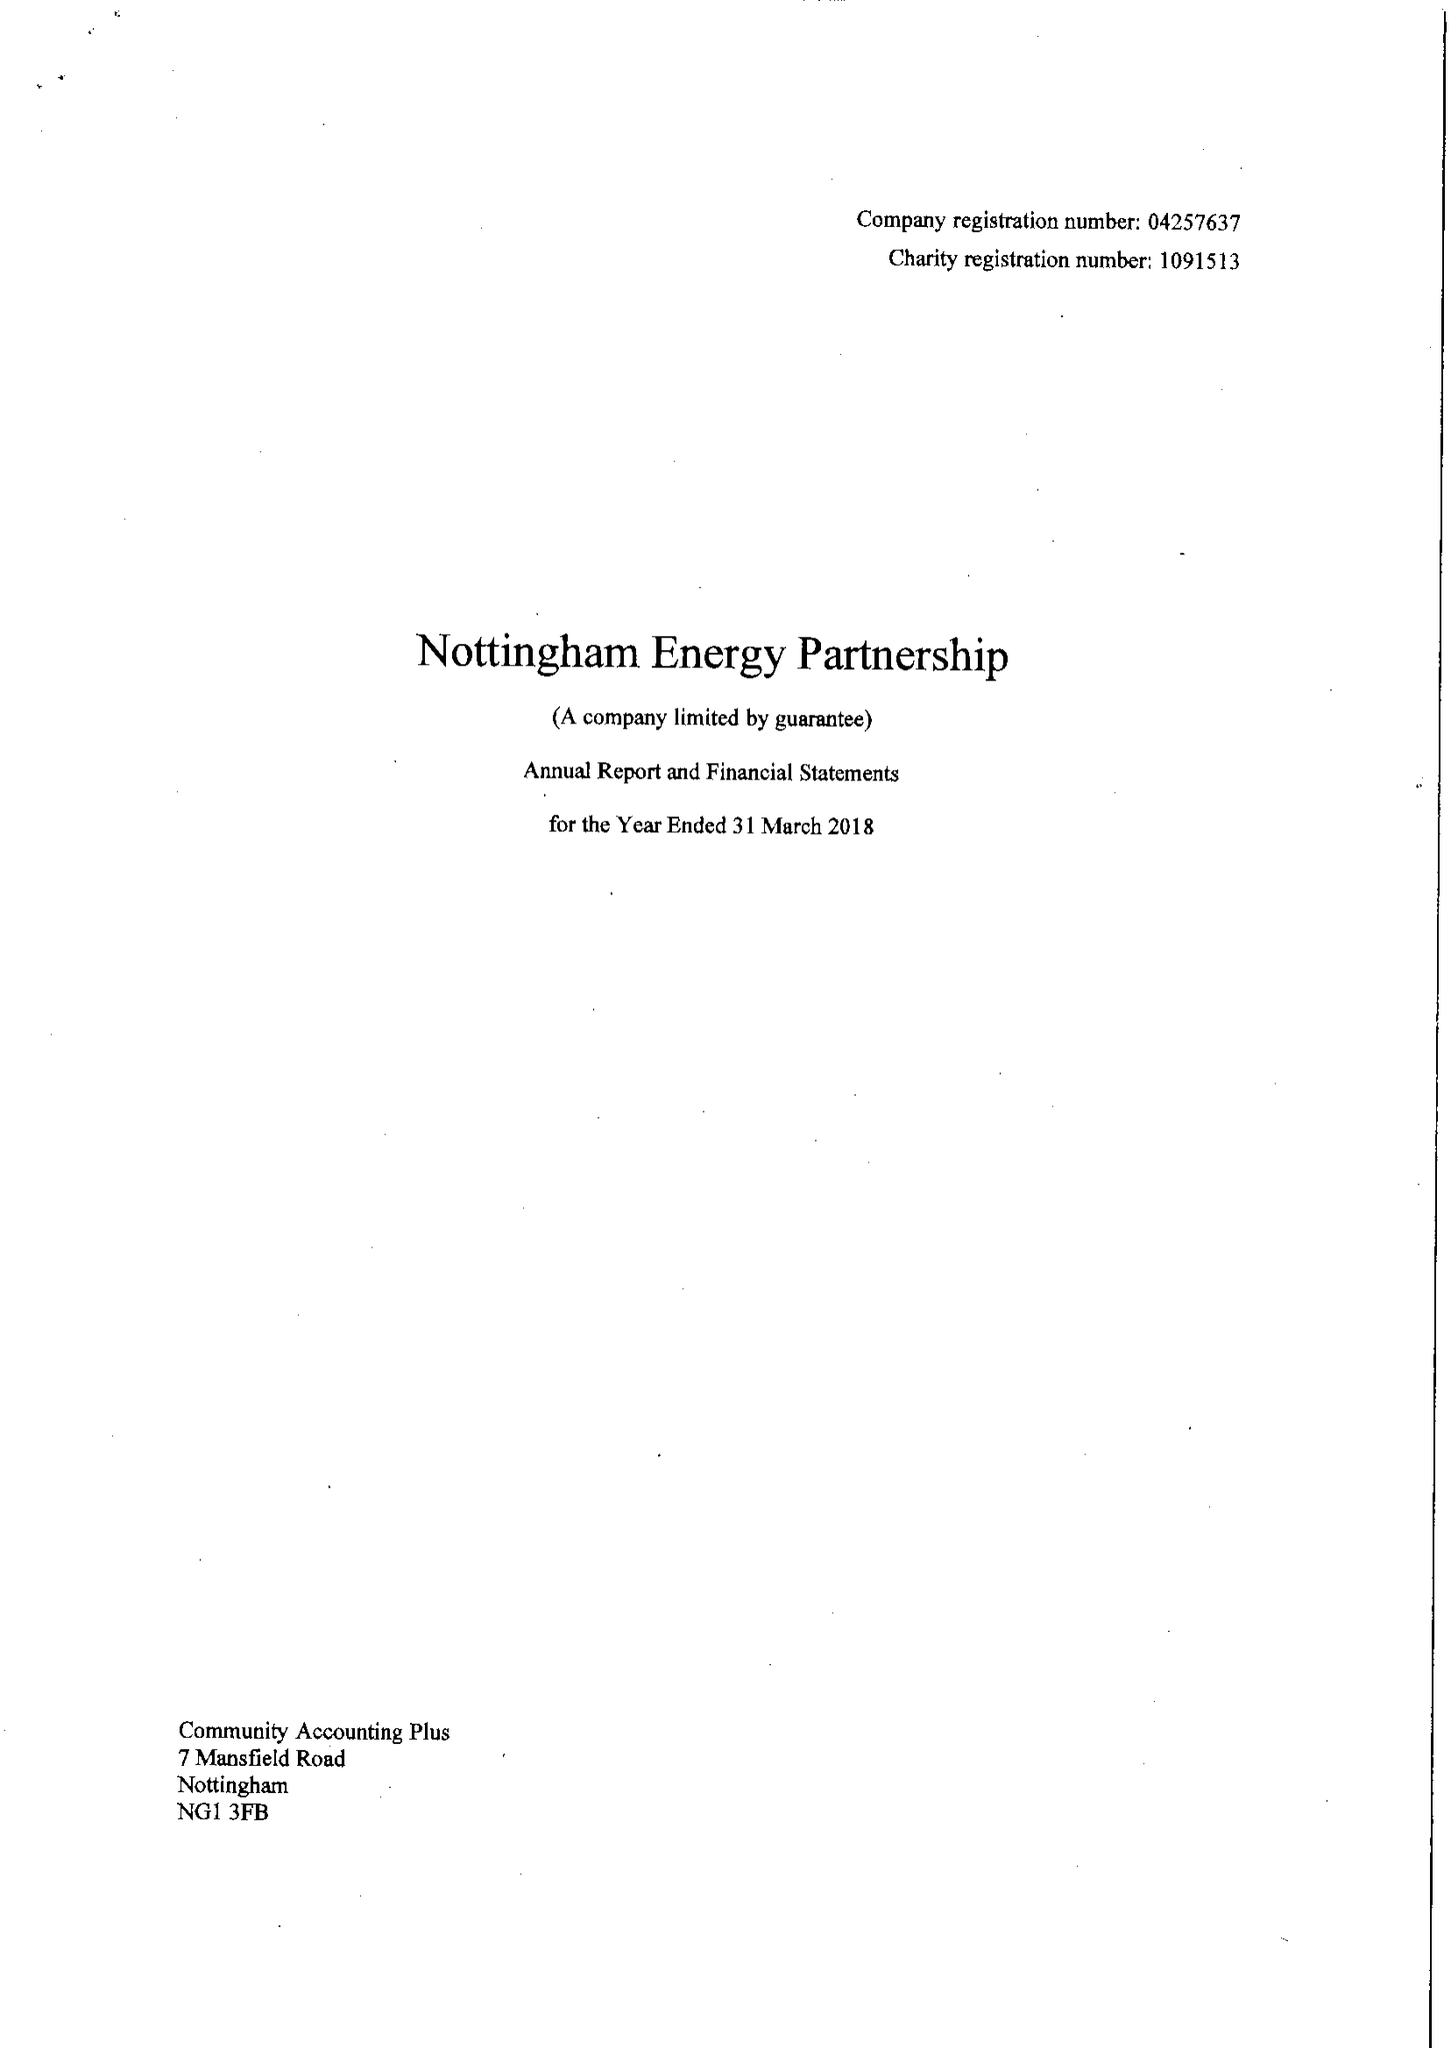What is the value for the charity_name?
Answer the question using a single word or phrase. Nottingham Energy Partnership 